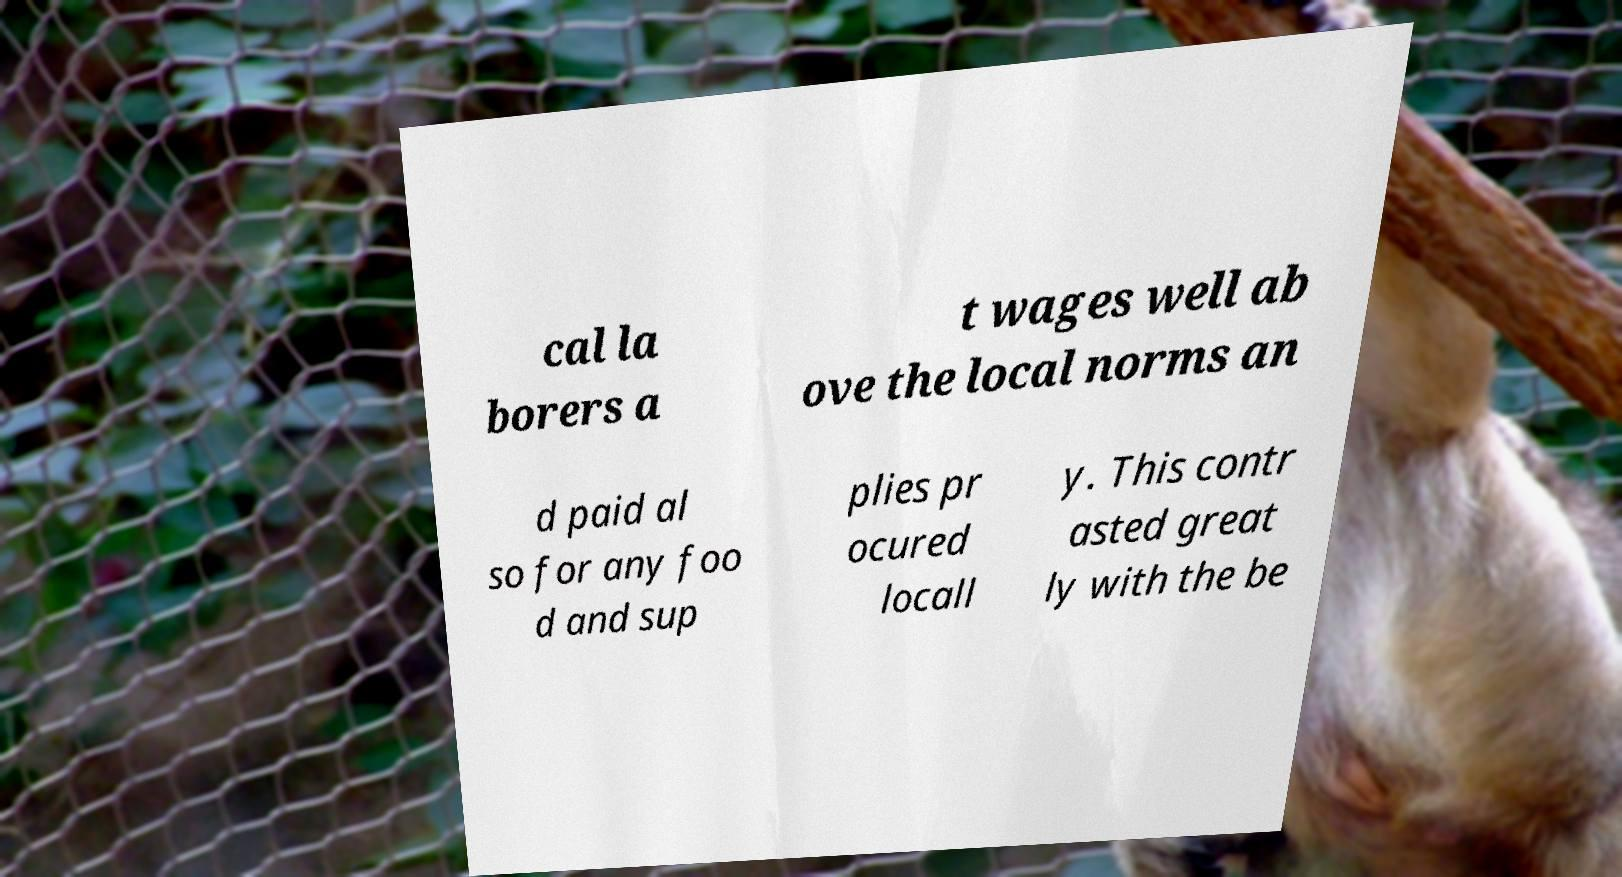Could you extract and type out the text from this image? cal la borers a t wages well ab ove the local norms an d paid al so for any foo d and sup plies pr ocured locall y. This contr asted great ly with the be 